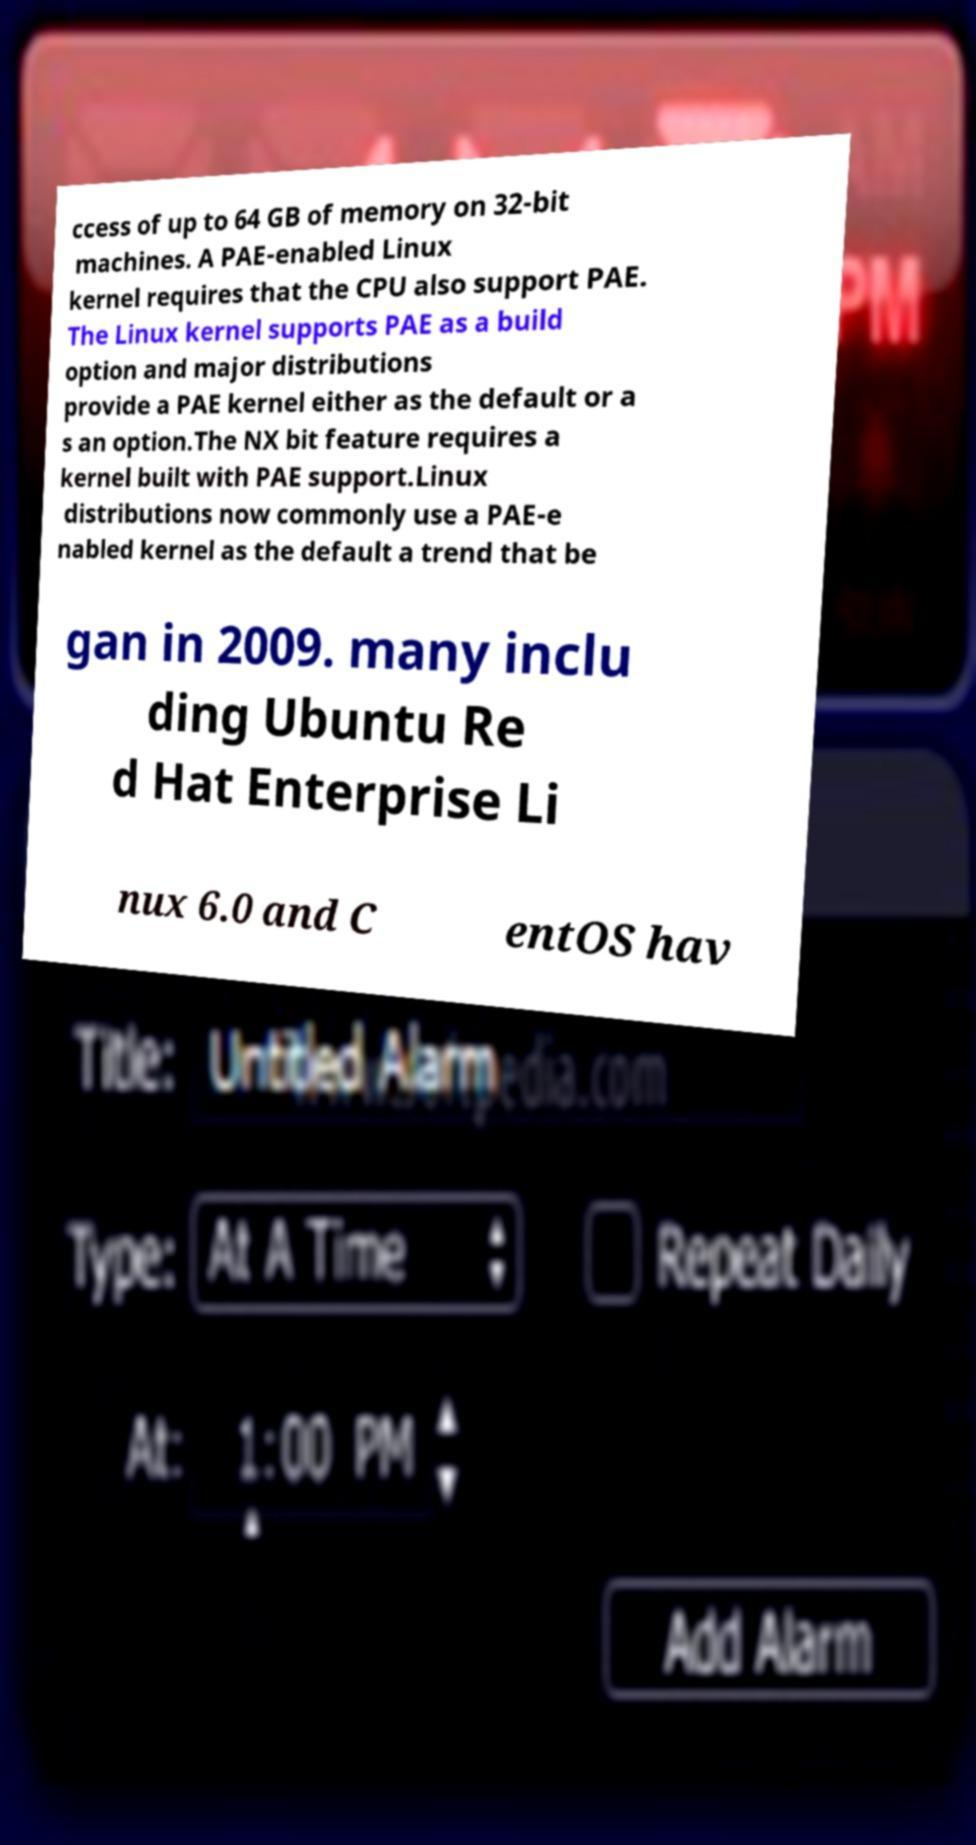Please read and relay the text visible in this image. What does it say? ccess of up to 64 GB of memory on 32-bit machines. A PAE-enabled Linux kernel requires that the CPU also support PAE. The Linux kernel supports PAE as a build option and major distributions provide a PAE kernel either as the default or a s an option.The NX bit feature requires a kernel built with PAE support.Linux distributions now commonly use a PAE-e nabled kernel as the default a trend that be gan in 2009. many inclu ding Ubuntu Re d Hat Enterprise Li nux 6.0 and C entOS hav 